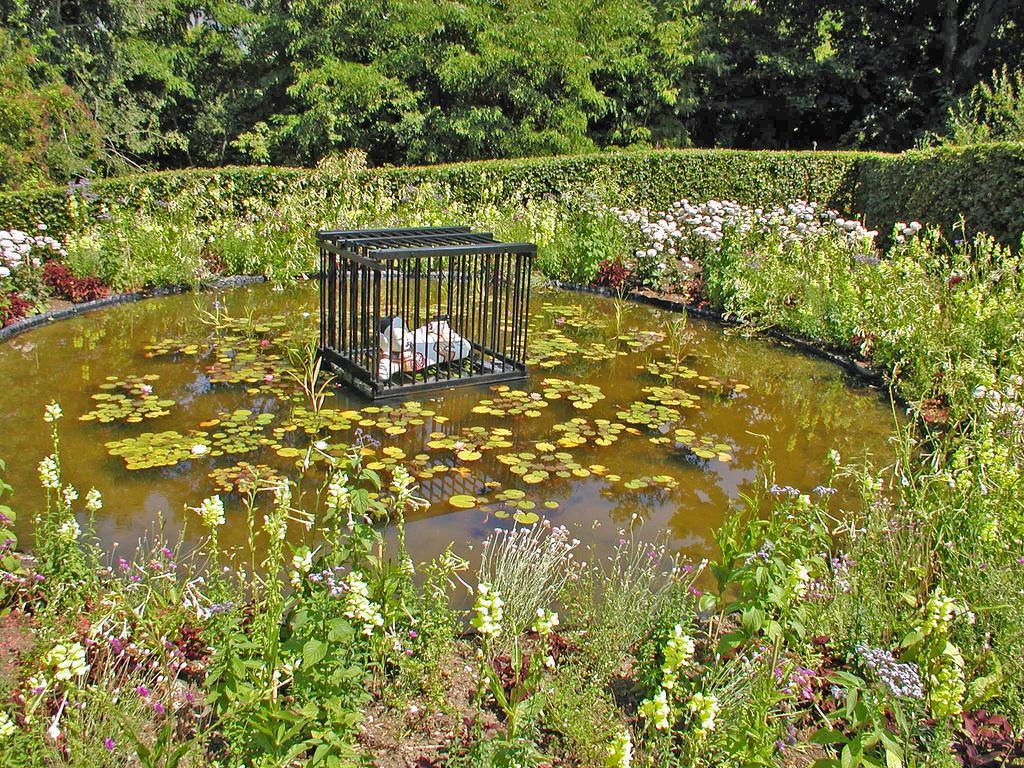How would you summarize this image in a sentence or two? In the center of the image there is a cage in a pond. At the bottom of the image there are flowers and plants. In the background there are trees, fencing, plants and flowers. 